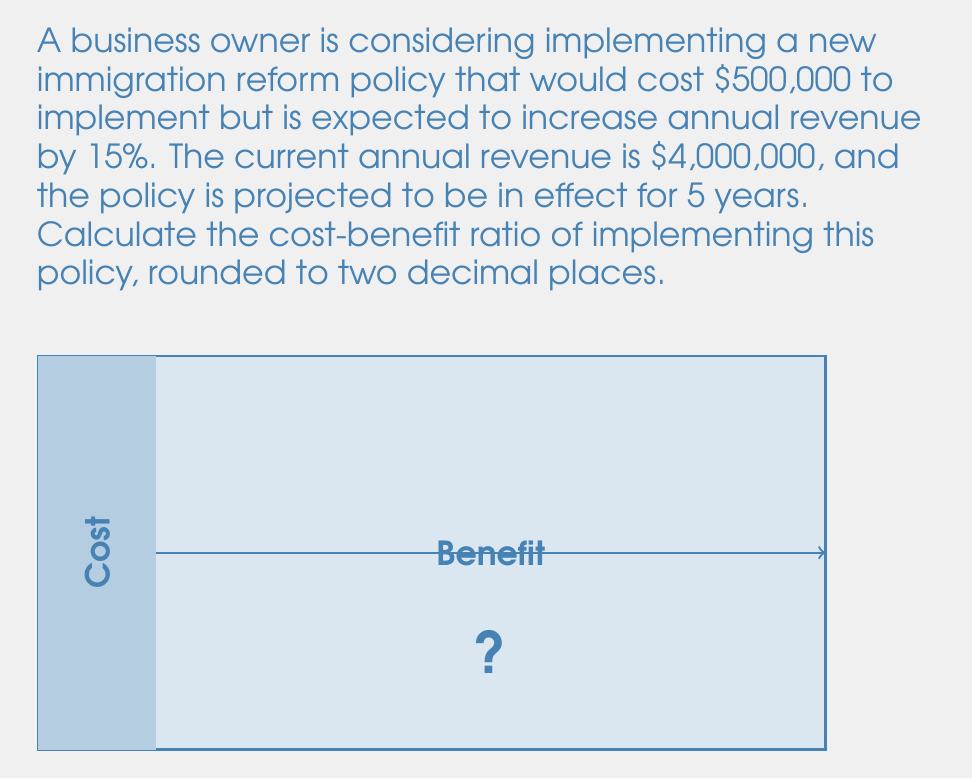Provide a solution to this math problem. To calculate the cost-benefit ratio, we need to follow these steps:

1) Calculate the total cost:
   The total cost is the implementation cost: $500,000

2) Calculate the total benefit:
   a) Current annual revenue: $4,000,000
   b) Increase in revenue: 15% of $4,000,000
      $4,000,000 \times 0.15 = $600,000 per year
   c) Total benefit over 5 years: $600,000 \times 5 = $3,000,000

3) Calculate the cost-benefit ratio:
   Cost-Benefit Ratio = $\frac{\text{Total Benefit}}{\text{Total Cost}}$
   
   $$\text{Cost-Benefit Ratio} = \frac{3,000,000}{500,000} = 6$$

4) Round to two decimal places:
   6.00

Therefore, the cost-benefit ratio is 6.00, meaning for every dollar spent on implementing the policy, the business owner can expect to gain $6.00 in benefits over the 5-year period.
Answer: 6.00 